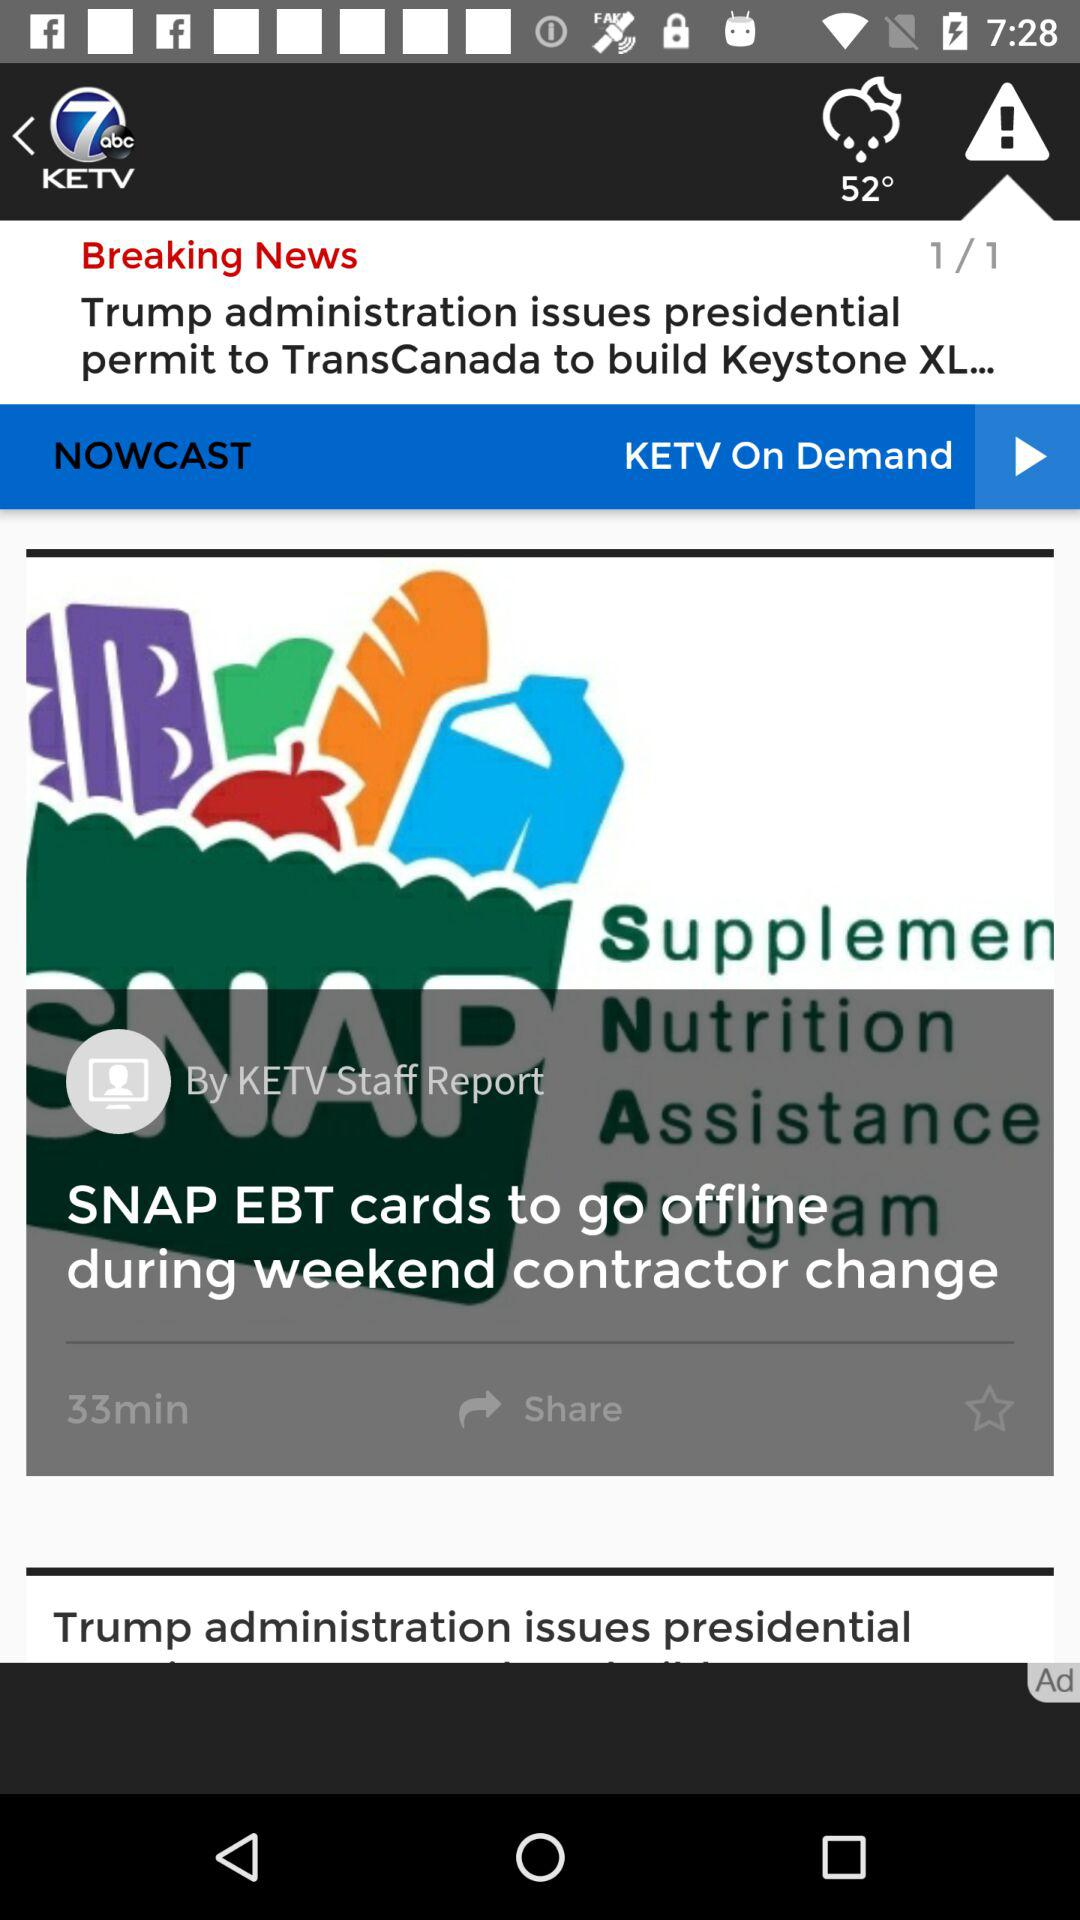How many minutes ago was the news posted? The news was posted 33 minutes ago. 